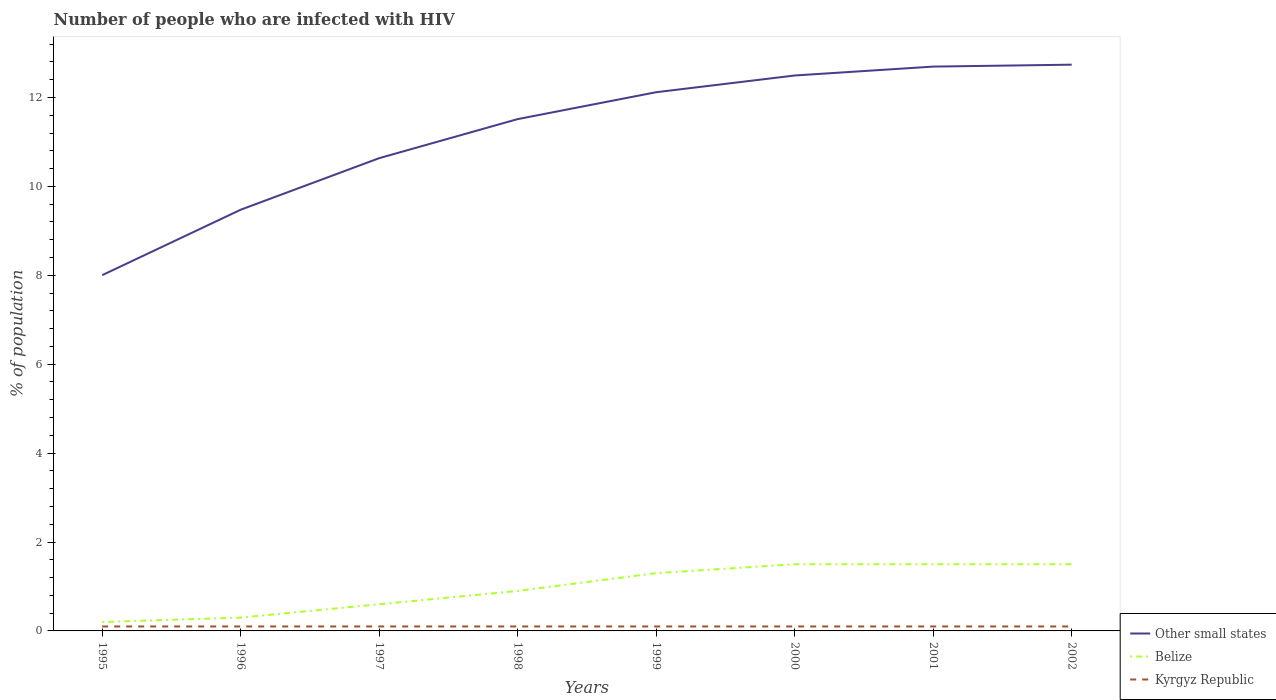Is the number of lines equal to the number of legend labels?
Provide a short and direct response. Yes. In which year was the percentage of HIV infected population in in Kyrgyz Republic maximum?
Your answer should be compact. 1995. What is the difference between the highest and the second highest percentage of HIV infected population in in Other small states?
Offer a very short reply. 4.74. Is the percentage of HIV infected population in in Other small states strictly greater than the percentage of HIV infected population in in Belize over the years?
Offer a very short reply. No. How many lines are there?
Offer a terse response. 3. How many years are there in the graph?
Provide a succinct answer. 8. What is the difference between two consecutive major ticks on the Y-axis?
Your answer should be very brief. 2. Does the graph contain grids?
Provide a succinct answer. No. Where does the legend appear in the graph?
Make the answer very short. Bottom right. How many legend labels are there?
Make the answer very short. 3. How are the legend labels stacked?
Give a very brief answer. Vertical. What is the title of the graph?
Ensure brevity in your answer.  Number of people who are infected with HIV. Does "Turks and Caicos Islands" appear as one of the legend labels in the graph?
Your answer should be compact. No. What is the label or title of the X-axis?
Your response must be concise. Years. What is the label or title of the Y-axis?
Your answer should be compact. % of population. What is the % of population of Other small states in 1995?
Provide a short and direct response. 8. What is the % of population in Other small states in 1996?
Offer a very short reply. 9.48. What is the % of population of Belize in 1996?
Your response must be concise. 0.3. What is the % of population in Kyrgyz Republic in 1996?
Make the answer very short. 0.1. What is the % of population in Other small states in 1997?
Provide a short and direct response. 10.64. What is the % of population of Belize in 1997?
Your answer should be very brief. 0.6. What is the % of population in Other small states in 1998?
Offer a very short reply. 11.51. What is the % of population of Belize in 1998?
Offer a terse response. 0.9. What is the % of population in Kyrgyz Republic in 1998?
Provide a succinct answer. 0.1. What is the % of population of Other small states in 1999?
Provide a succinct answer. 12.12. What is the % of population in Kyrgyz Republic in 1999?
Ensure brevity in your answer.  0.1. What is the % of population in Other small states in 2000?
Ensure brevity in your answer.  12.5. What is the % of population of Belize in 2000?
Offer a terse response. 1.5. What is the % of population of Other small states in 2001?
Provide a succinct answer. 12.7. What is the % of population of Belize in 2001?
Give a very brief answer. 1.5. What is the % of population in Other small states in 2002?
Provide a short and direct response. 12.74. What is the % of population in Kyrgyz Republic in 2002?
Provide a succinct answer. 0.1. Across all years, what is the maximum % of population of Other small states?
Ensure brevity in your answer.  12.74. Across all years, what is the maximum % of population of Belize?
Keep it short and to the point. 1.5. Across all years, what is the minimum % of population of Other small states?
Your response must be concise. 8. What is the total % of population in Other small states in the graph?
Offer a terse response. 89.68. What is the total % of population in Kyrgyz Republic in the graph?
Offer a terse response. 0.8. What is the difference between the % of population in Other small states in 1995 and that in 1996?
Ensure brevity in your answer.  -1.47. What is the difference between the % of population in Other small states in 1995 and that in 1997?
Your answer should be very brief. -2.63. What is the difference between the % of population of Kyrgyz Republic in 1995 and that in 1997?
Ensure brevity in your answer.  0. What is the difference between the % of population of Other small states in 1995 and that in 1998?
Ensure brevity in your answer.  -3.51. What is the difference between the % of population in Kyrgyz Republic in 1995 and that in 1998?
Ensure brevity in your answer.  0. What is the difference between the % of population of Other small states in 1995 and that in 1999?
Provide a succinct answer. -4.12. What is the difference between the % of population in Belize in 1995 and that in 1999?
Provide a succinct answer. -1.1. What is the difference between the % of population of Kyrgyz Republic in 1995 and that in 1999?
Your answer should be compact. 0. What is the difference between the % of population in Other small states in 1995 and that in 2000?
Ensure brevity in your answer.  -4.49. What is the difference between the % of population in Belize in 1995 and that in 2000?
Your answer should be compact. -1.3. What is the difference between the % of population of Other small states in 1995 and that in 2001?
Offer a very short reply. -4.69. What is the difference between the % of population of Kyrgyz Republic in 1995 and that in 2001?
Give a very brief answer. 0. What is the difference between the % of population in Other small states in 1995 and that in 2002?
Ensure brevity in your answer.  -4.74. What is the difference between the % of population of Kyrgyz Republic in 1995 and that in 2002?
Your response must be concise. 0. What is the difference between the % of population in Other small states in 1996 and that in 1997?
Your response must be concise. -1.16. What is the difference between the % of population in Other small states in 1996 and that in 1998?
Offer a very short reply. -2.04. What is the difference between the % of population of Belize in 1996 and that in 1998?
Provide a succinct answer. -0.6. What is the difference between the % of population in Kyrgyz Republic in 1996 and that in 1998?
Offer a very short reply. 0. What is the difference between the % of population of Other small states in 1996 and that in 1999?
Keep it short and to the point. -2.64. What is the difference between the % of population of Kyrgyz Republic in 1996 and that in 1999?
Your answer should be very brief. 0. What is the difference between the % of population in Other small states in 1996 and that in 2000?
Make the answer very short. -3.02. What is the difference between the % of population of Belize in 1996 and that in 2000?
Offer a terse response. -1.2. What is the difference between the % of population of Other small states in 1996 and that in 2001?
Make the answer very short. -3.22. What is the difference between the % of population of Kyrgyz Republic in 1996 and that in 2001?
Give a very brief answer. 0. What is the difference between the % of population of Other small states in 1996 and that in 2002?
Provide a succinct answer. -3.26. What is the difference between the % of population in Belize in 1996 and that in 2002?
Make the answer very short. -1.2. What is the difference between the % of population in Other small states in 1997 and that in 1998?
Keep it short and to the point. -0.88. What is the difference between the % of population in Belize in 1997 and that in 1998?
Offer a terse response. -0.3. What is the difference between the % of population in Other small states in 1997 and that in 1999?
Make the answer very short. -1.48. What is the difference between the % of population of Other small states in 1997 and that in 2000?
Provide a short and direct response. -1.86. What is the difference between the % of population of Belize in 1997 and that in 2000?
Offer a terse response. -0.9. What is the difference between the % of population in Kyrgyz Republic in 1997 and that in 2000?
Ensure brevity in your answer.  0. What is the difference between the % of population of Other small states in 1997 and that in 2001?
Your answer should be very brief. -2.06. What is the difference between the % of population of Other small states in 1997 and that in 2002?
Provide a short and direct response. -2.1. What is the difference between the % of population of Other small states in 1998 and that in 1999?
Your answer should be compact. -0.61. What is the difference between the % of population in Other small states in 1998 and that in 2000?
Provide a short and direct response. -0.98. What is the difference between the % of population of Belize in 1998 and that in 2000?
Make the answer very short. -0.6. What is the difference between the % of population of Other small states in 1998 and that in 2001?
Give a very brief answer. -1.18. What is the difference between the % of population in Belize in 1998 and that in 2001?
Ensure brevity in your answer.  -0.6. What is the difference between the % of population in Other small states in 1998 and that in 2002?
Keep it short and to the point. -1.22. What is the difference between the % of population in Belize in 1998 and that in 2002?
Make the answer very short. -0.6. What is the difference between the % of population in Other small states in 1999 and that in 2000?
Offer a very short reply. -0.38. What is the difference between the % of population of Belize in 1999 and that in 2000?
Offer a very short reply. -0.2. What is the difference between the % of population in Kyrgyz Republic in 1999 and that in 2000?
Give a very brief answer. 0. What is the difference between the % of population in Other small states in 1999 and that in 2001?
Your answer should be very brief. -0.58. What is the difference between the % of population in Kyrgyz Republic in 1999 and that in 2001?
Provide a succinct answer. 0. What is the difference between the % of population in Other small states in 1999 and that in 2002?
Ensure brevity in your answer.  -0.62. What is the difference between the % of population in Kyrgyz Republic in 1999 and that in 2002?
Your answer should be very brief. 0. What is the difference between the % of population in Other small states in 2000 and that in 2001?
Make the answer very short. -0.2. What is the difference between the % of population in Kyrgyz Republic in 2000 and that in 2001?
Offer a terse response. 0. What is the difference between the % of population in Other small states in 2000 and that in 2002?
Provide a succinct answer. -0.24. What is the difference between the % of population of Other small states in 2001 and that in 2002?
Your answer should be compact. -0.04. What is the difference between the % of population of Belize in 2001 and that in 2002?
Give a very brief answer. 0. What is the difference between the % of population in Kyrgyz Republic in 2001 and that in 2002?
Keep it short and to the point. 0. What is the difference between the % of population of Other small states in 1995 and the % of population of Belize in 1996?
Make the answer very short. 7.7. What is the difference between the % of population of Other small states in 1995 and the % of population of Kyrgyz Republic in 1996?
Make the answer very short. 7.9. What is the difference between the % of population in Belize in 1995 and the % of population in Kyrgyz Republic in 1996?
Your answer should be compact. 0.1. What is the difference between the % of population of Other small states in 1995 and the % of population of Belize in 1997?
Make the answer very short. 7.4. What is the difference between the % of population of Other small states in 1995 and the % of population of Kyrgyz Republic in 1997?
Keep it short and to the point. 7.9. What is the difference between the % of population in Other small states in 1995 and the % of population in Belize in 1998?
Your answer should be very brief. 7.1. What is the difference between the % of population of Other small states in 1995 and the % of population of Kyrgyz Republic in 1998?
Offer a very short reply. 7.9. What is the difference between the % of population of Belize in 1995 and the % of population of Kyrgyz Republic in 1998?
Your response must be concise. 0.1. What is the difference between the % of population in Other small states in 1995 and the % of population in Belize in 1999?
Give a very brief answer. 6.7. What is the difference between the % of population of Other small states in 1995 and the % of population of Kyrgyz Republic in 1999?
Give a very brief answer. 7.9. What is the difference between the % of population in Other small states in 1995 and the % of population in Belize in 2000?
Provide a short and direct response. 6.5. What is the difference between the % of population in Other small states in 1995 and the % of population in Kyrgyz Republic in 2000?
Provide a short and direct response. 7.9. What is the difference between the % of population in Other small states in 1995 and the % of population in Belize in 2001?
Provide a short and direct response. 6.5. What is the difference between the % of population in Other small states in 1995 and the % of population in Kyrgyz Republic in 2001?
Offer a terse response. 7.9. What is the difference between the % of population of Belize in 1995 and the % of population of Kyrgyz Republic in 2001?
Offer a terse response. 0.1. What is the difference between the % of population of Other small states in 1995 and the % of population of Belize in 2002?
Offer a very short reply. 6.5. What is the difference between the % of population of Other small states in 1995 and the % of population of Kyrgyz Republic in 2002?
Keep it short and to the point. 7.9. What is the difference between the % of population in Other small states in 1996 and the % of population in Belize in 1997?
Offer a terse response. 8.88. What is the difference between the % of population in Other small states in 1996 and the % of population in Kyrgyz Republic in 1997?
Offer a very short reply. 9.38. What is the difference between the % of population of Other small states in 1996 and the % of population of Belize in 1998?
Provide a succinct answer. 8.58. What is the difference between the % of population of Other small states in 1996 and the % of population of Kyrgyz Republic in 1998?
Your answer should be very brief. 9.38. What is the difference between the % of population of Other small states in 1996 and the % of population of Belize in 1999?
Make the answer very short. 8.18. What is the difference between the % of population of Other small states in 1996 and the % of population of Kyrgyz Republic in 1999?
Your answer should be compact. 9.38. What is the difference between the % of population in Other small states in 1996 and the % of population in Belize in 2000?
Keep it short and to the point. 7.98. What is the difference between the % of population in Other small states in 1996 and the % of population in Kyrgyz Republic in 2000?
Provide a succinct answer. 9.38. What is the difference between the % of population of Belize in 1996 and the % of population of Kyrgyz Republic in 2000?
Offer a very short reply. 0.2. What is the difference between the % of population in Other small states in 1996 and the % of population in Belize in 2001?
Ensure brevity in your answer.  7.98. What is the difference between the % of population in Other small states in 1996 and the % of population in Kyrgyz Republic in 2001?
Your answer should be compact. 9.38. What is the difference between the % of population of Belize in 1996 and the % of population of Kyrgyz Republic in 2001?
Provide a succinct answer. 0.2. What is the difference between the % of population in Other small states in 1996 and the % of population in Belize in 2002?
Your answer should be very brief. 7.98. What is the difference between the % of population of Other small states in 1996 and the % of population of Kyrgyz Republic in 2002?
Your answer should be compact. 9.38. What is the difference between the % of population in Belize in 1996 and the % of population in Kyrgyz Republic in 2002?
Your response must be concise. 0.2. What is the difference between the % of population of Other small states in 1997 and the % of population of Belize in 1998?
Offer a terse response. 9.74. What is the difference between the % of population in Other small states in 1997 and the % of population in Kyrgyz Republic in 1998?
Provide a succinct answer. 10.54. What is the difference between the % of population of Belize in 1997 and the % of population of Kyrgyz Republic in 1998?
Provide a short and direct response. 0.5. What is the difference between the % of population in Other small states in 1997 and the % of population in Belize in 1999?
Keep it short and to the point. 9.34. What is the difference between the % of population in Other small states in 1997 and the % of population in Kyrgyz Republic in 1999?
Provide a succinct answer. 10.54. What is the difference between the % of population in Belize in 1997 and the % of population in Kyrgyz Republic in 1999?
Your answer should be compact. 0.5. What is the difference between the % of population of Other small states in 1997 and the % of population of Belize in 2000?
Your answer should be compact. 9.14. What is the difference between the % of population of Other small states in 1997 and the % of population of Kyrgyz Republic in 2000?
Offer a very short reply. 10.54. What is the difference between the % of population of Belize in 1997 and the % of population of Kyrgyz Republic in 2000?
Give a very brief answer. 0.5. What is the difference between the % of population in Other small states in 1997 and the % of population in Belize in 2001?
Provide a short and direct response. 9.14. What is the difference between the % of population of Other small states in 1997 and the % of population of Kyrgyz Republic in 2001?
Your answer should be compact. 10.54. What is the difference between the % of population in Belize in 1997 and the % of population in Kyrgyz Republic in 2001?
Keep it short and to the point. 0.5. What is the difference between the % of population in Other small states in 1997 and the % of population in Belize in 2002?
Offer a very short reply. 9.14. What is the difference between the % of population of Other small states in 1997 and the % of population of Kyrgyz Republic in 2002?
Your answer should be compact. 10.54. What is the difference between the % of population in Other small states in 1998 and the % of population in Belize in 1999?
Keep it short and to the point. 10.21. What is the difference between the % of population in Other small states in 1998 and the % of population in Kyrgyz Republic in 1999?
Your answer should be very brief. 11.41. What is the difference between the % of population of Other small states in 1998 and the % of population of Belize in 2000?
Ensure brevity in your answer.  10.01. What is the difference between the % of population in Other small states in 1998 and the % of population in Kyrgyz Republic in 2000?
Offer a very short reply. 11.41. What is the difference between the % of population of Belize in 1998 and the % of population of Kyrgyz Republic in 2000?
Give a very brief answer. 0.8. What is the difference between the % of population of Other small states in 1998 and the % of population of Belize in 2001?
Keep it short and to the point. 10.01. What is the difference between the % of population of Other small states in 1998 and the % of population of Kyrgyz Republic in 2001?
Offer a very short reply. 11.41. What is the difference between the % of population of Other small states in 1998 and the % of population of Belize in 2002?
Your answer should be very brief. 10.01. What is the difference between the % of population of Other small states in 1998 and the % of population of Kyrgyz Republic in 2002?
Ensure brevity in your answer.  11.41. What is the difference between the % of population in Belize in 1998 and the % of population in Kyrgyz Republic in 2002?
Your response must be concise. 0.8. What is the difference between the % of population of Other small states in 1999 and the % of population of Belize in 2000?
Keep it short and to the point. 10.62. What is the difference between the % of population in Other small states in 1999 and the % of population in Kyrgyz Republic in 2000?
Offer a terse response. 12.02. What is the difference between the % of population in Belize in 1999 and the % of population in Kyrgyz Republic in 2000?
Offer a very short reply. 1.2. What is the difference between the % of population of Other small states in 1999 and the % of population of Belize in 2001?
Offer a very short reply. 10.62. What is the difference between the % of population in Other small states in 1999 and the % of population in Kyrgyz Republic in 2001?
Your response must be concise. 12.02. What is the difference between the % of population of Belize in 1999 and the % of population of Kyrgyz Republic in 2001?
Provide a short and direct response. 1.2. What is the difference between the % of population in Other small states in 1999 and the % of population in Belize in 2002?
Provide a succinct answer. 10.62. What is the difference between the % of population in Other small states in 1999 and the % of population in Kyrgyz Republic in 2002?
Provide a short and direct response. 12.02. What is the difference between the % of population in Belize in 1999 and the % of population in Kyrgyz Republic in 2002?
Offer a terse response. 1.2. What is the difference between the % of population in Other small states in 2000 and the % of population in Belize in 2001?
Provide a short and direct response. 11. What is the difference between the % of population of Other small states in 2000 and the % of population of Kyrgyz Republic in 2001?
Provide a short and direct response. 12.4. What is the difference between the % of population of Other small states in 2000 and the % of population of Belize in 2002?
Provide a succinct answer. 11. What is the difference between the % of population of Other small states in 2000 and the % of population of Kyrgyz Republic in 2002?
Offer a terse response. 12.4. What is the difference between the % of population in Other small states in 2001 and the % of population in Belize in 2002?
Offer a very short reply. 11.2. What is the difference between the % of population of Other small states in 2001 and the % of population of Kyrgyz Republic in 2002?
Give a very brief answer. 12.6. What is the difference between the % of population in Belize in 2001 and the % of population in Kyrgyz Republic in 2002?
Offer a very short reply. 1.4. What is the average % of population in Other small states per year?
Provide a succinct answer. 11.21. What is the average % of population of Kyrgyz Republic per year?
Give a very brief answer. 0.1. In the year 1995, what is the difference between the % of population of Other small states and % of population of Belize?
Ensure brevity in your answer.  7.8. In the year 1995, what is the difference between the % of population of Other small states and % of population of Kyrgyz Republic?
Your response must be concise. 7.9. In the year 1996, what is the difference between the % of population of Other small states and % of population of Belize?
Make the answer very short. 9.18. In the year 1996, what is the difference between the % of population in Other small states and % of population in Kyrgyz Republic?
Give a very brief answer. 9.38. In the year 1996, what is the difference between the % of population in Belize and % of population in Kyrgyz Republic?
Your answer should be compact. 0.2. In the year 1997, what is the difference between the % of population in Other small states and % of population in Belize?
Give a very brief answer. 10.04. In the year 1997, what is the difference between the % of population in Other small states and % of population in Kyrgyz Republic?
Your response must be concise. 10.54. In the year 1998, what is the difference between the % of population of Other small states and % of population of Belize?
Your answer should be very brief. 10.61. In the year 1998, what is the difference between the % of population of Other small states and % of population of Kyrgyz Republic?
Your answer should be very brief. 11.41. In the year 1998, what is the difference between the % of population of Belize and % of population of Kyrgyz Republic?
Provide a short and direct response. 0.8. In the year 1999, what is the difference between the % of population in Other small states and % of population in Belize?
Provide a succinct answer. 10.82. In the year 1999, what is the difference between the % of population of Other small states and % of population of Kyrgyz Republic?
Ensure brevity in your answer.  12.02. In the year 2000, what is the difference between the % of population in Other small states and % of population in Belize?
Provide a succinct answer. 11. In the year 2000, what is the difference between the % of population of Other small states and % of population of Kyrgyz Republic?
Your answer should be compact. 12.4. In the year 2000, what is the difference between the % of population of Belize and % of population of Kyrgyz Republic?
Your answer should be very brief. 1.4. In the year 2001, what is the difference between the % of population of Other small states and % of population of Belize?
Provide a short and direct response. 11.2. In the year 2001, what is the difference between the % of population in Other small states and % of population in Kyrgyz Republic?
Ensure brevity in your answer.  12.6. In the year 2001, what is the difference between the % of population of Belize and % of population of Kyrgyz Republic?
Offer a terse response. 1.4. In the year 2002, what is the difference between the % of population of Other small states and % of population of Belize?
Your answer should be compact. 11.24. In the year 2002, what is the difference between the % of population of Other small states and % of population of Kyrgyz Republic?
Keep it short and to the point. 12.64. In the year 2002, what is the difference between the % of population of Belize and % of population of Kyrgyz Republic?
Your answer should be compact. 1.4. What is the ratio of the % of population of Other small states in 1995 to that in 1996?
Give a very brief answer. 0.84. What is the ratio of the % of population of Kyrgyz Republic in 1995 to that in 1996?
Offer a very short reply. 1. What is the ratio of the % of population in Other small states in 1995 to that in 1997?
Your answer should be very brief. 0.75. What is the ratio of the % of population in Other small states in 1995 to that in 1998?
Keep it short and to the point. 0.7. What is the ratio of the % of population of Belize in 1995 to that in 1998?
Offer a very short reply. 0.22. What is the ratio of the % of population of Other small states in 1995 to that in 1999?
Give a very brief answer. 0.66. What is the ratio of the % of population in Belize in 1995 to that in 1999?
Your response must be concise. 0.15. What is the ratio of the % of population in Kyrgyz Republic in 1995 to that in 1999?
Provide a succinct answer. 1. What is the ratio of the % of population of Other small states in 1995 to that in 2000?
Your response must be concise. 0.64. What is the ratio of the % of population of Belize in 1995 to that in 2000?
Offer a very short reply. 0.13. What is the ratio of the % of population in Kyrgyz Republic in 1995 to that in 2000?
Your answer should be very brief. 1. What is the ratio of the % of population in Other small states in 1995 to that in 2001?
Your answer should be very brief. 0.63. What is the ratio of the % of population in Belize in 1995 to that in 2001?
Provide a succinct answer. 0.13. What is the ratio of the % of population in Other small states in 1995 to that in 2002?
Provide a short and direct response. 0.63. What is the ratio of the % of population of Belize in 1995 to that in 2002?
Provide a succinct answer. 0.13. What is the ratio of the % of population of Kyrgyz Republic in 1995 to that in 2002?
Make the answer very short. 1. What is the ratio of the % of population in Other small states in 1996 to that in 1997?
Offer a terse response. 0.89. What is the ratio of the % of population of Belize in 1996 to that in 1997?
Keep it short and to the point. 0.5. What is the ratio of the % of population of Kyrgyz Republic in 1996 to that in 1997?
Your response must be concise. 1. What is the ratio of the % of population in Other small states in 1996 to that in 1998?
Provide a succinct answer. 0.82. What is the ratio of the % of population in Belize in 1996 to that in 1998?
Offer a terse response. 0.33. What is the ratio of the % of population in Other small states in 1996 to that in 1999?
Your answer should be very brief. 0.78. What is the ratio of the % of population in Belize in 1996 to that in 1999?
Your answer should be very brief. 0.23. What is the ratio of the % of population of Other small states in 1996 to that in 2000?
Your response must be concise. 0.76. What is the ratio of the % of population of Other small states in 1996 to that in 2001?
Your response must be concise. 0.75. What is the ratio of the % of population of Belize in 1996 to that in 2001?
Offer a terse response. 0.2. What is the ratio of the % of population of Other small states in 1996 to that in 2002?
Provide a short and direct response. 0.74. What is the ratio of the % of population in Kyrgyz Republic in 1996 to that in 2002?
Offer a terse response. 1. What is the ratio of the % of population in Other small states in 1997 to that in 1998?
Keep it short and to the point. 0.92. What is the ratio of the % of population of Belize in 1997 to that in 1998?
Ensure brevity in your answer.  0.67. What is the ratio of the % of population in Kyrgyz Republic in 1997 to that in 1998?
Offer a terse response. 1. What is the ratio of the % of population in Other small states in 1997 to that in 1999?
Offer a very short reply. 0.88. What is the ratio of the % of population in Belize in 1997 to that in 1999?
Make the answer very short. 0.46. What is the ratio of the % of population in Other small states in 1997 to that in 2000?
Keep it short and to the point. 0.85. What is the ratio of the % of population of Other small states in 1997 to that in 2001?
Ensure brevity in your answer.  0.84. What is the ratio of the % of population of Other small states in 1997 to that in 2002?
Your answer should be compact. 0.83. What is the ratio of the % of population in Kyrgyz Republic in 1997 to that in 2002?
Offer a terse response. 1. What is the ratio of the % of population in Other small states in 1998 to that in 1999?
Offer a very short reply. 0.95. What is the ratio of the % of population of Belize in 1998 to that in 1999?
Provide a succinct answer. 0.69. What is the ratio of the % of population in Other small states in 1998 to that in 2000?
Make the answer very short. 0.92. What is the ratio of the % of population of Belize in 1998 to that in 2000?
Offer a very short reply. 0.6. What is the ratio of the % of population of Other small states in 1998 to that in 2001?
Give a very brief answer. 0.91. What is the ratio of the % of population of Belize in 1998 to that in 2001?
Your answer should be compact. 0.6. What is the ratio of the % of population of Other small states in 1998 to that in 2002?
Make the answer very short. 0.9. What is the ratio of the % of population in Other small states in 1999 to that in 2000?
Give a very brief answer. 0.97. What is the ratio of the % of population of Belize in 1999 to that in 2000?
Provide a succinct answer. 0.87. What is the ratio of the % of population of Other small states in 1999 to that in 2001?
Make the answer very short. 0.95. What is the ratio of the % of population of Belize in 1999 to that in 2001?
Your answer should be very brief. 0.87. What is the ratio of the % of population of Kyrgyz Republic in 1999 to that in 2001?
Offer a terse response. 1. What is the ratio of the % of population of Other small states in 1999 to that in 2002?
Provide a succinct answer. 0.95. What is the ratio of the % of population in Belize in 1999 to that in 2002?
Provide a short and direct response. 0.87. What is the ratio of the % of population in Other small states in 2000 to that in 2001?
Provide a short and direct response. 0.98. What is the ratio of the % of population in Belize in 2000 to that in 2001?
Provide a short and direct response. 1. What is the ratio of the % of population in Kyrgyz Republic in 2000 to that in 2001?
Provide a short and direct response. 1. What is the ratio of the % of population of Other small states in 2000 to that in 2002?
Your response must be concise. 0.98. What is the ratio of the % of population in Kyrgyz Republic in 2000 to that in 2002?
Provide a short and direct response. 1. What is the ratio of the % of population in Other small states in 2001 to that in 2002?
Provide a succinct answer. 1. What is the ratio of the % of population in Belize in 2001 to that in 2002?
Offer a very short reply. 1. What is the difference between the highest and the second highest % of population of Other small states?
Make the answer very short. 0.04. What is the difference between the highest and the second highest % of population of Belize?
Provide a succinct answer. 0. What is the difference between the highest and the lowest % of population of Other small states?
Your response must be concise. 4.74. What is the difference between the highest and the lowest % of population in Belize?
Give a very brief answer. 1.3. 